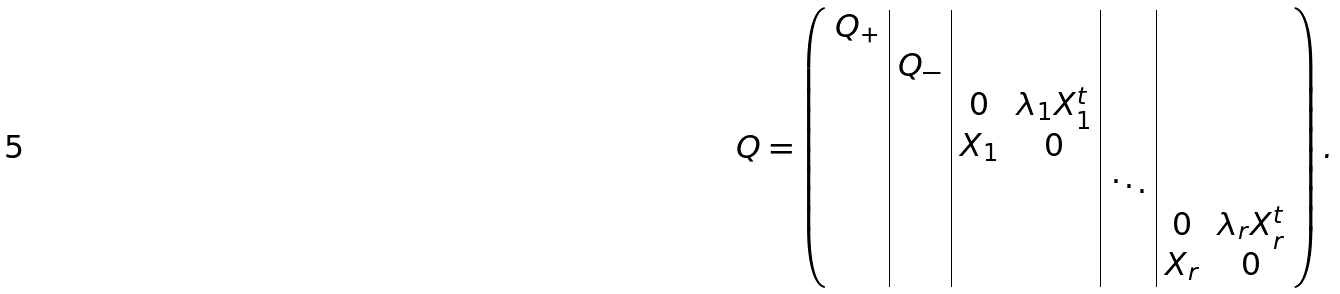Convert formula to latex. <formula><loc_0><loc_0><loc_500><loc_500>Q = \left ( \begin{array} { c | c | c c | c | c c } Q _ { + } & & & & & & \\ & Q _ { - } & & & & & \\ & & 0 & \lambda _ { 1 } X _ { 1 } ^ { t } & & & \\ & & X _ { 1 } & 0 & & & \\ & & & & \ddots & & \\ & & & & & 0 & \lambda _ { r } X _ { r } ^ { t } \\ & & & & & X _ { r } & 0 \\ \end{array} \right ) .</formula> 